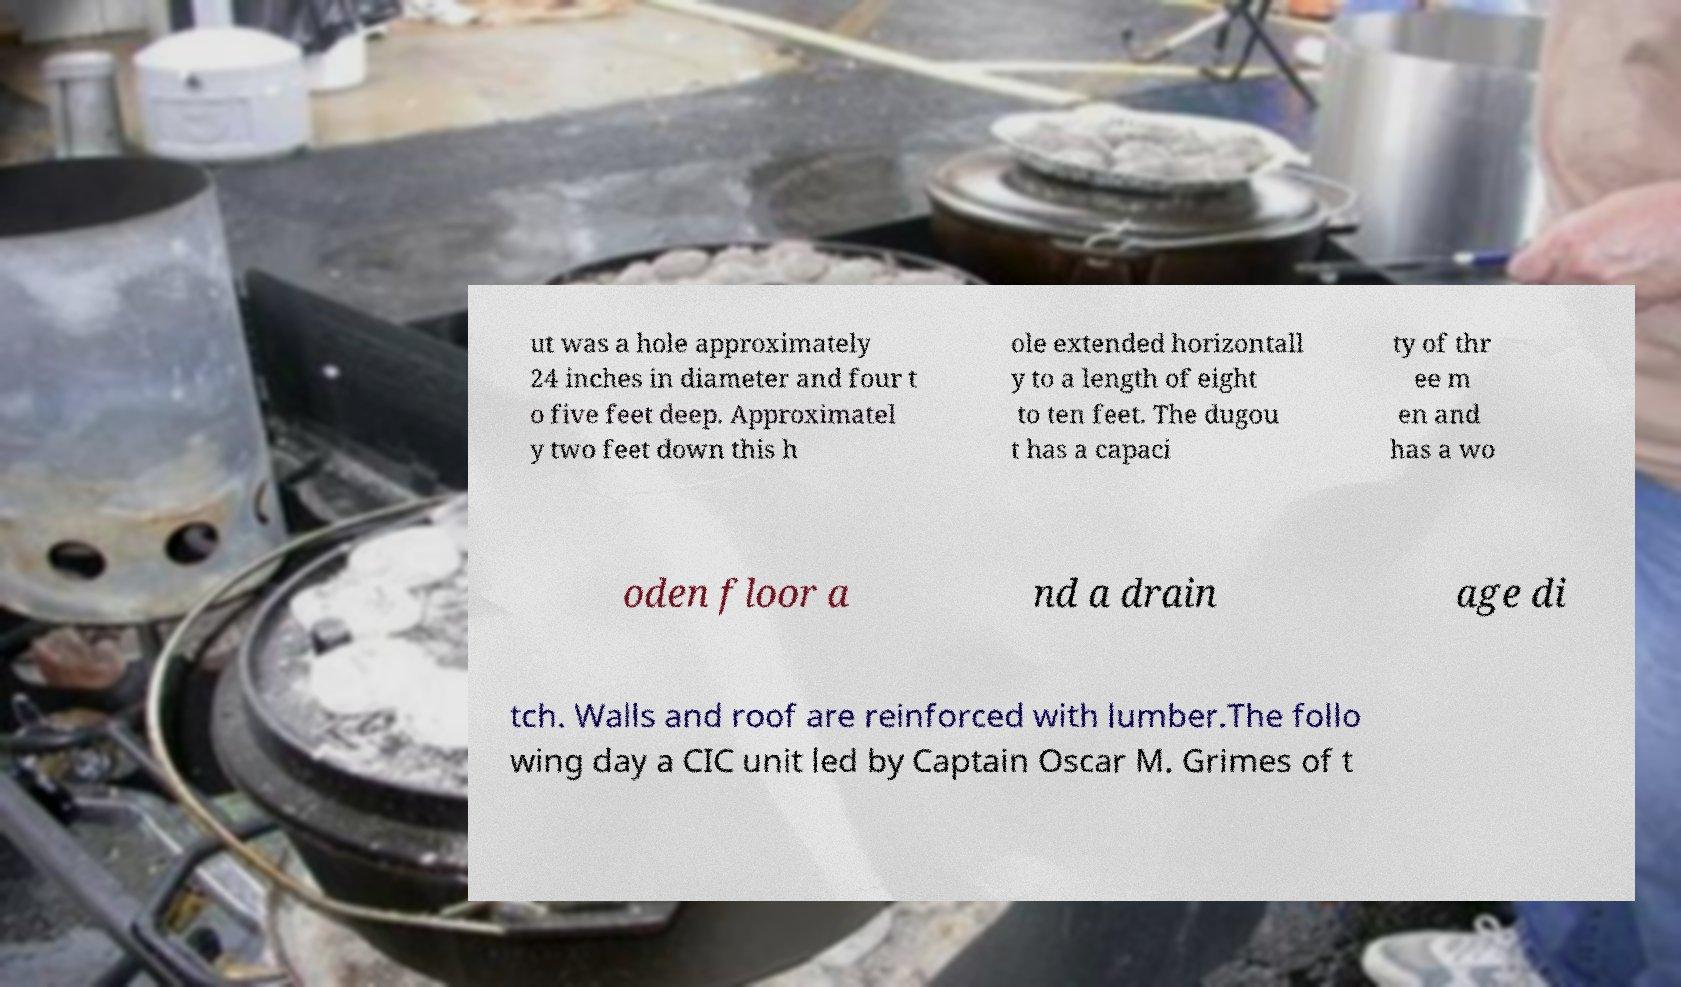I need the written content from this picture converted into text. Can you do that? ut was a hole approximately 24 inches in diameter and four t o five feet deep. Approximatel y two feet down this h ole extended horizontall y to a length of eight to ten feet. The dugou t has a capaci ty of thr ee m en and has a wo oden floor a nd a drain age di tch. Walls and roof are reinforced with lumber.The follo wing day a CIC unit led by Captain Oscar M. Grimes of t 